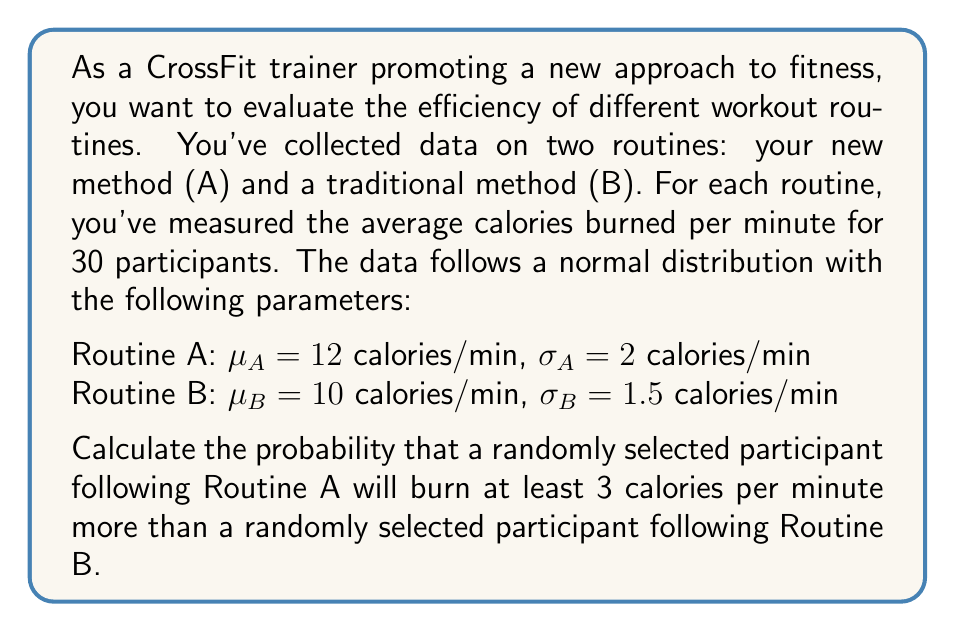Can you answer this question? To solve this problem, we need to use the properties of normal distributions and the concept of the difference between two independent normal random variables.

1) Let $X$ be the calories burned per minute for Routine A, and $Y$ be the calories burned per minute for Routine B.

   $X \sim N(\mu_A = 12, \sigma_A^2 = 4)$
   $Y \sim N(\mu_B = 10, \sigma_B^2 = 2.25)$

2) We want to find $P(X - Y \geq 3)$

3) The difference between two independent normal random variables is also normally distributed. Let $Z = X - Y$. Then:

   $Z \sim N(\mu_Z, \sigma_Z^2)$

   where:
   $\mu_Z = \mu_A - \mu_B = 12 - 10 = 2$
   $\sigma_Z^2 = \sigma_A^2 + \sigma_B^2 = 4 + 2.25 = 6.25$
   $\sigma_Z = \sqrt{6.25} = 2.5$

4) Now we need to find $P(Z \geq 3)$

5) We can standardize this to a standard normal distribution:

   $P(Z \geq 3) = P(\frac{Z - \mu_Z}{\sigma_Z} \geq \frac{3 - 2}{2.5}) = P(Z' \geq 0.4)$

   where $Z'$ is the standard normal variable.

6) Using a standard normal table or calculator, we can find:

   $P(Z' \geq 0.4) = 1 - P(Z' < 0.4) = 1 - 0.6554 = 0.3446$

Therefore, the probability that a randomly selected participant following Routine A will burn at least 3 calories per minute more than a randomly selected participant following Routine B is approximately 0.3446 or 34.46%.
Answer: 0.3446 or 34.46% 